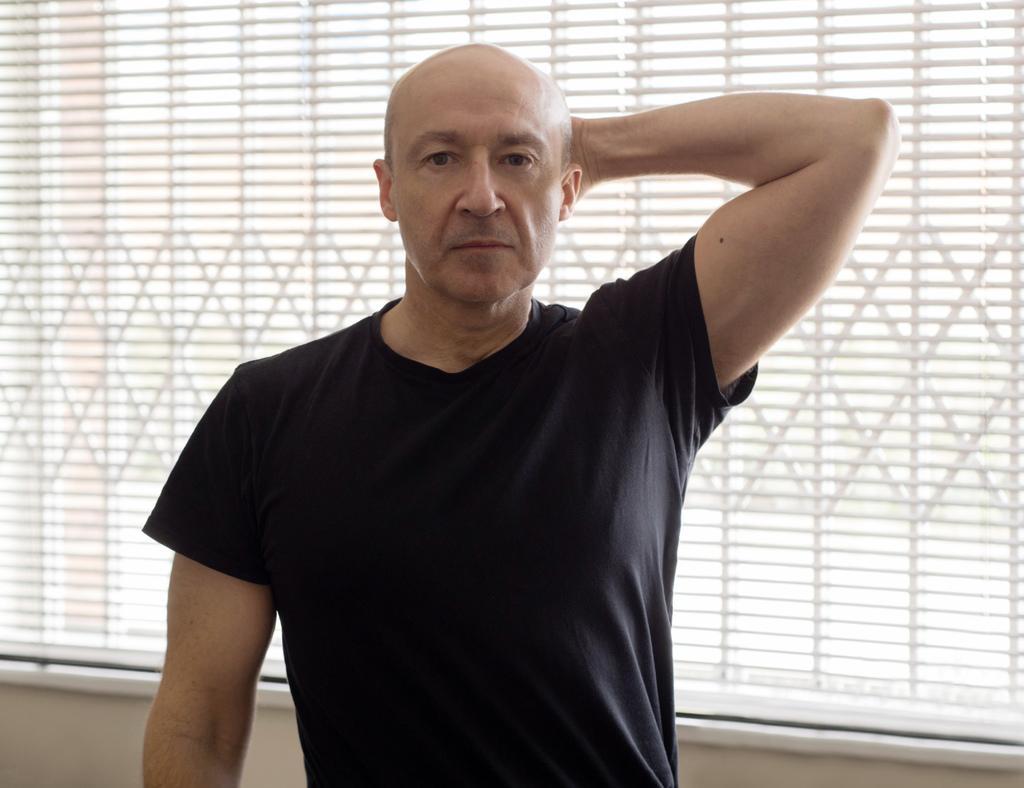In one or two sentences, can you explain what this image depicts? In the image we can see a person wearing a black color T-shirt and standing, in the background we can see a window. 